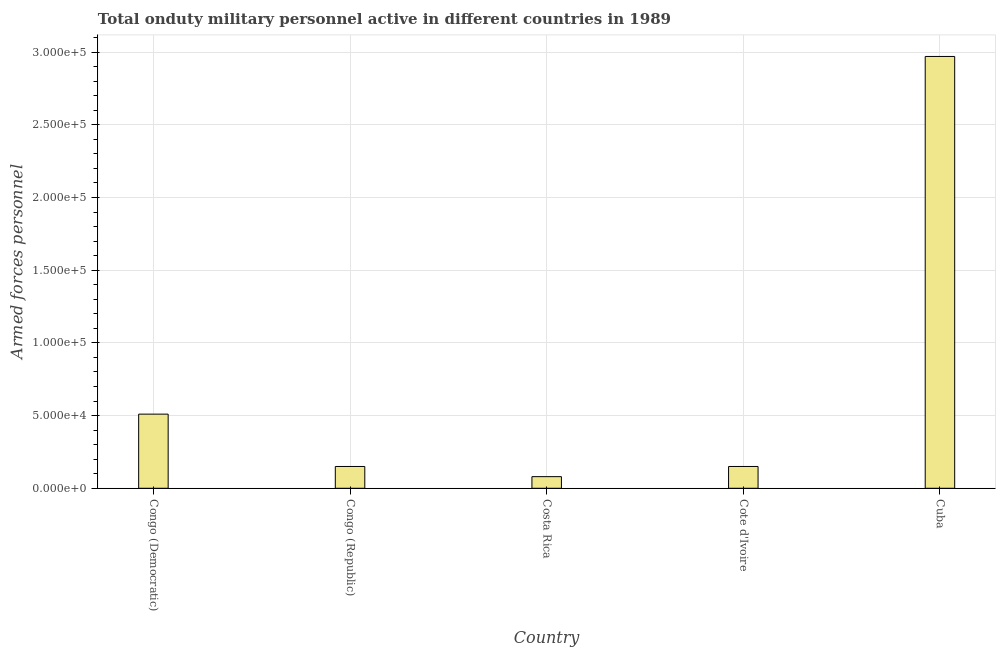Does the graph contain any zero values?
Make the answer very short. No. What is the title of the graph?
Give a very brief answer. Total onduty military personnel active in different countries in 1989. What is the label or title of the Y-axis?
Make the answer very short. Armed forces personnel. What is the number of armed forces personnel in Cote d'Ivoire?
Your response must be concise. 1.50e+04. Across all countries, what is the maximum number of armed forces personnel?
Give a very brief answer. 2.97e+05. Across all countries, what is the minimum number of armed forces personnel?
Your response must be concise. 8000. In which country was the number of armed forces personnel maximum?
Provide a succinct answer. Cuba. In which country was the number of armed forces personnel minimum?
Your answer should be compact. Costa Rica. What is the sum of the number of armed forces personnel?
Your answer should be very brief. 3.86e+05. What is the difference between the number of armed forces personnel in Congo (Republic) and Costa Rica?
Your answer should be very brief. 7000. What is the average number of armed forces personnel per country?
Offer a terse response. 7.72e+04. What is the median number of armed forces personnel?
Your response must be concise. 1.50e+04. In how many countries, is the number of armed forces personnel greater than 250000 ?
Give a very brief answer. 1. What is the ratio of the number of armed forces personnel in Congo (Democratic) to that in Costa Rica?
Provide a succinct answer. 6.38. Is the number of armed forces personnel in Costa Rica less than that in Cuba?
Provide a succinct answer. Yes. Is the difference between the number of armed forces personnel in Costa Rica and Cuba greater than the difference between any two countries?
Your answer should be very brief. Yes. What is the difference between the highest and the second highest number of armed forces personnel?
Your answer should be very brief. 2.46e+05. What is the difference between the highest and the lowest number of armed forces personnel?
Offer a terse response. 2.89e+05. In how many countries, is the number of armed forces personnel greater than the average number of armed forces personnel taken over all countries?
Provide a succinct answer. 1. How many bars are there?
Make the answer very short. 5. What is the Armed forces personnel of Congo (Democratic)?
Provide a short and direct response. 5.10e+04. What is the Armed forces personnel of Congo (Republic)?
Your response must be concise. 1.50e+04. What is the Armed forces personnel of Costa Rica?
Provide a succinct answer. 8000. What is the Armed forces personnel in Cote d'Ivoire?
Offer a very short reply. 1.50e+04. What is the Armed forces personnel in Cuba?
Your answer should be compact. 2.97e+05. What is the difference between the Armed forces personnel in Congo (Democratic) and Congo (Republic)?
Keep it short and to the point. 3.60e+04. What is the difference between the Armed forces personnel in Congo (Democratic) and Costa Rica?
Provide a succinct answer. 4.30e+04. What is the difference between the Armed forces personnel in Congo (Democratic) and Cote d'Ivoire?
Offer a terse response. 3.60e+04. What is the difference between the Armed forces personnel in Congo (Democratic) and Cuba?
Ensure brevity in your answer.  -2.46e+05. What is the difference between the Armed forces personnel in Congo (Republic) and Costa Rica?
Make the answer very short. 7000. What is the difference between the Armed forces personnel in Congo (Republic) and Cuba?
Provide a succinct answer. -2.82e+05. What is the difference between the Armed forces personnel in Costa Rica and Cote d'Ivoire?
Offer a terse response. -7000. What is the difference between the Armed forces personnel in Costa Rica and Cuba?
Your response must be concise. -2.89e+05. What is the difference between the Armed forces personnel in Cote d'Ivoire and Cuba?
Provide a short and direct response. -2.82e+05. What is the ratio of the Armed forces personnel in Congo (Democratic) to that in Congo (Republic)?
Your response must be concise. 3.4. What is the ratio of the Armed forces personnel in Congo (Democratic) to that in Costa Rica?
Ensure brevity in your answer.  6.38. What is the ratio of the Armed forces personnel in Congo (Democratic) to that in Cuba?
Give a very brief answer. 0.17. What is the ratio of the Armed forces personnel in Congo (Republic) to that in Costa Rica?
Provide a short and direct response. 1.88. What is the ratio of the Armed forces personnel in Congo (Republic) to that in Cote d'Ivoire?
Ensure brevity in your answer.  1. What is the ratio of the Armed forces personnel in Congo (Republic) to that in Cuba?
Make the answer very short. 0.05. What is the ratio of the Armed forces personnel in Costa Rica to that in Cote d'Ivoire?
Keep it short and to the point. 0.53. What is the ratio of the Armed forces personnel in Costa Rica to that in Cuba?
Ensure brevity in your answer.  0.03. What is the ratio of the Armed forces personnel in Cote d'Ivoire to that in Cuba?
Make the answer very short. 0.05. 